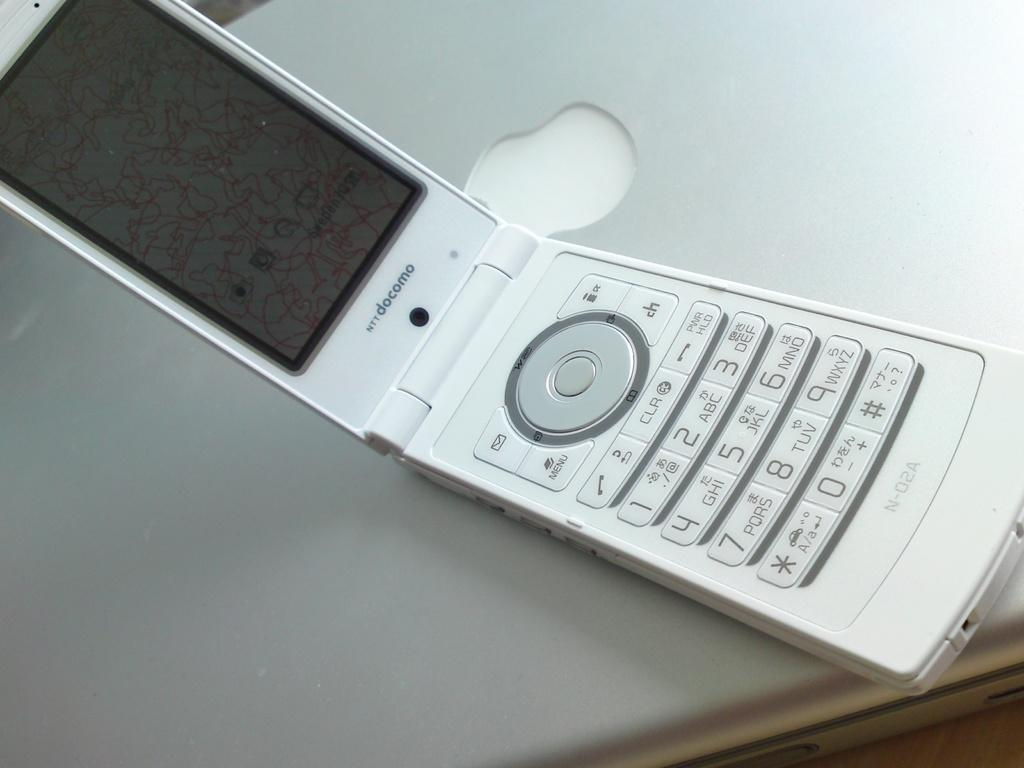<image>
Offer a succinct explanation of the picture presented. An NTTdocomo flip phone sits open on top of a laptop. 